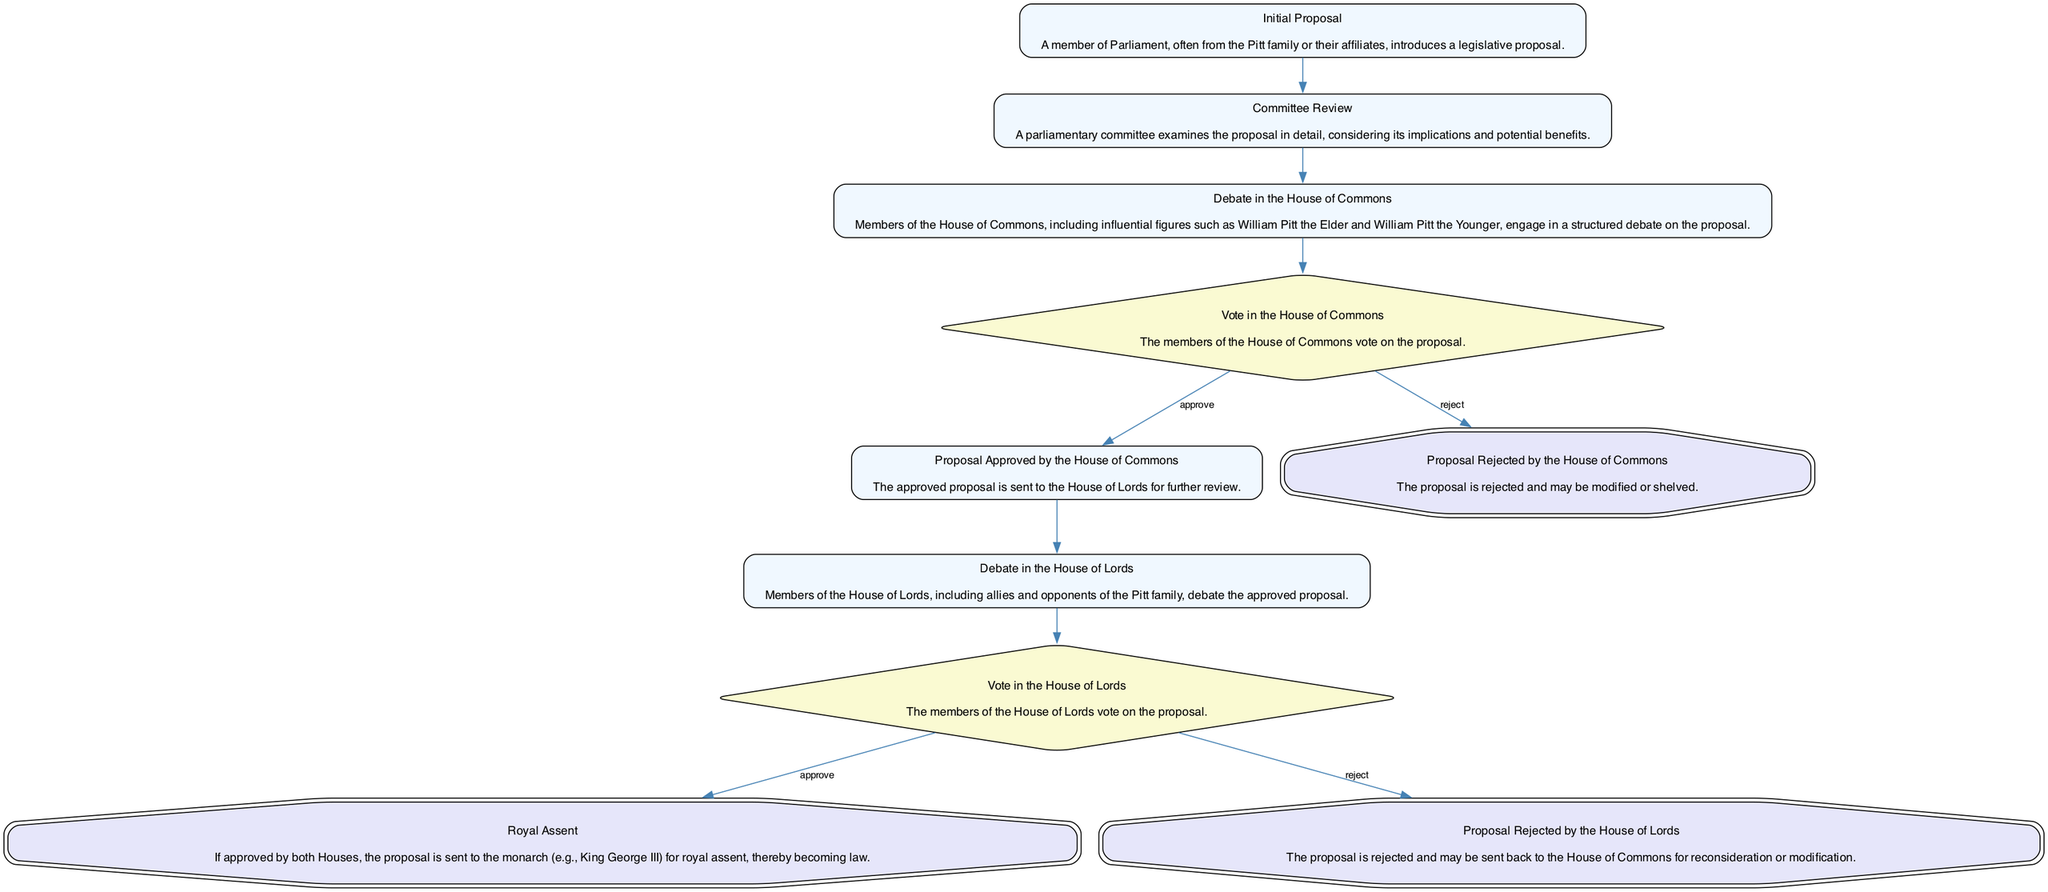What is the first step in the decision-making process? The first step, as shown in the diagram, is the "Initial Proposal," where a member of Parliament introduces a legislative proposal.
Answer: Initial Proposal How many options exist after the "Vote in the House of Commons"? In the diagram, there are two options after the "Vote in the House of Commons": "Proposal Approved by the House of Commons" and "Proposal Rejected by the House of Commons." Therefore, the number of options is 2.
Answer: 2 What happens after a proposal is approved by the House of Lords? After being approved by the House of Lords, the proposal proceeds to "Royal Assent," where it becomes law if granted by the monarch.
Answer: Royal Assent Which node follows the "Committee Review"? Following the "Committee Review," the next node is "Debate in the House of Commons."
Answer: Debate in the House of Commons What is the final node in the diagram? The final node in the diagram is "Royal Assent," which indicates the completion of the decision-making process if the proposal is approved by both Houses.
Answer: Royal Assent How many final outcomes are there in total? There are three final outcomes shown in the diagram: "Royal Assent," "Proposal Rejected by the House of Commons," and "Proposal Rejected by the House of Lords." Therefore, the total is 3.
Answer: 3 What step occurs between "Vote in the House of Lords" and "Royal Assent"? The step that occurs between "Vote in the House of Lords" and "Royal Assent" is the approval of the proposal by "Vote in the House of Lords."
Answer: Vote in the House of Lords Which members of Parliament participate in the "Debate in the House of Commons"? In the "Debate in the House of Commons," participation includes influential figures such as William Pitt the Elder and William Pitt the Younger.
Answer: William Pitt the Elder and William Pitt the Younger 